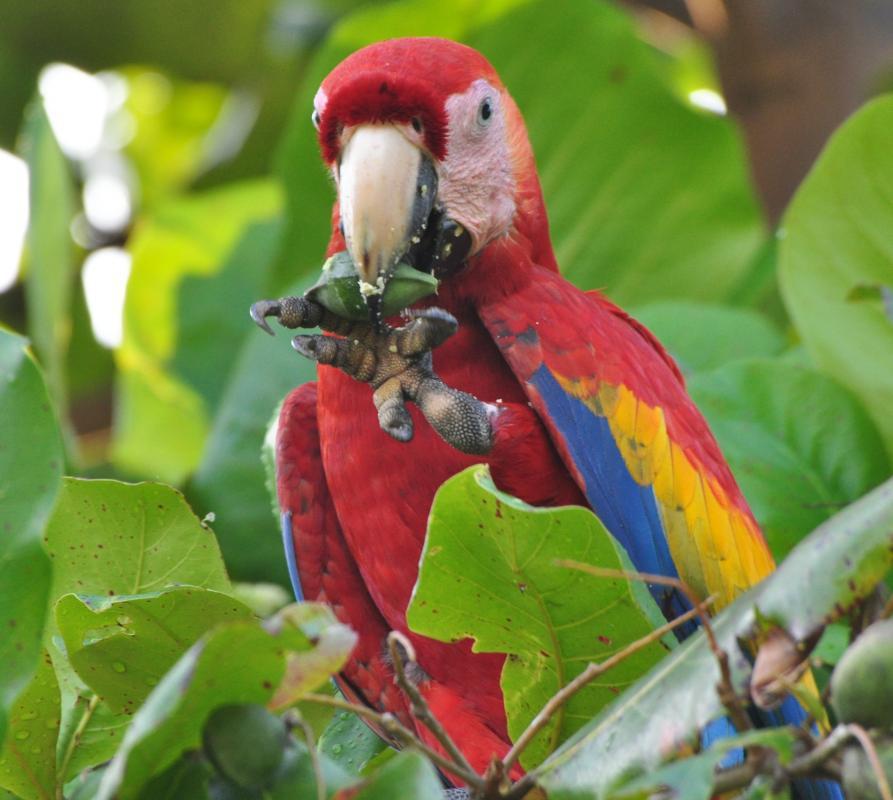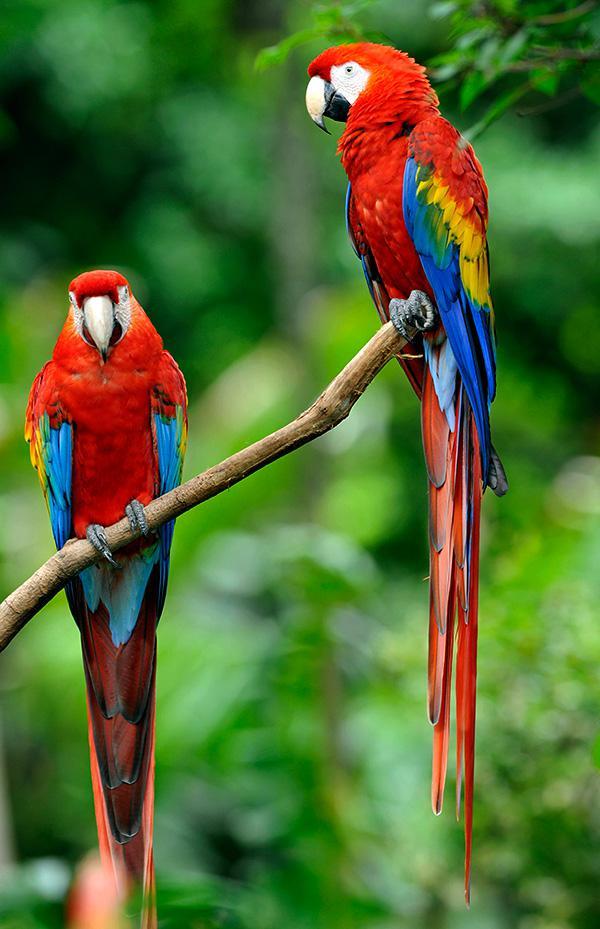The first image is the image on the left, the second image is the image on the right. Assess this claim about the two images: "A parrot is eating something in at least one of the images.". Correct or not? Answer yes or no. Yes. The first image is the image on the left, the second image is the image on the right. Given the left and right images, does the statement "At least one image shows a red-headed parrot lifting a kind of nut with one claw towards its beak." hold true? Answer yes or no. Yes. 